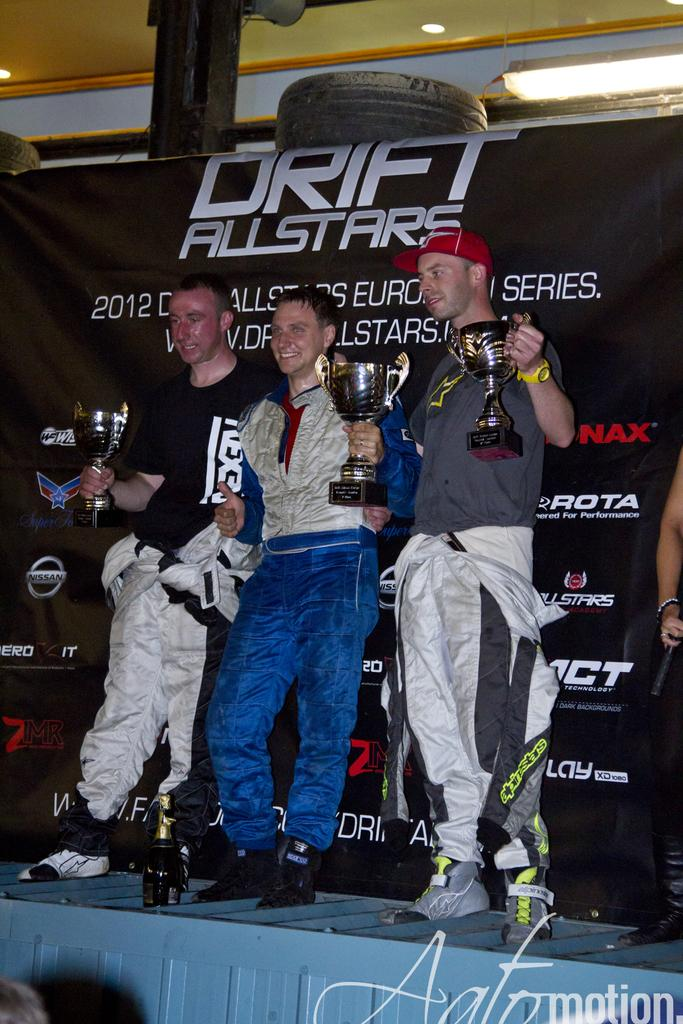<image>
Share a concise interpretation of the image provided. Three men stand on a stage and hold up trophies for a drifting comeptition. 